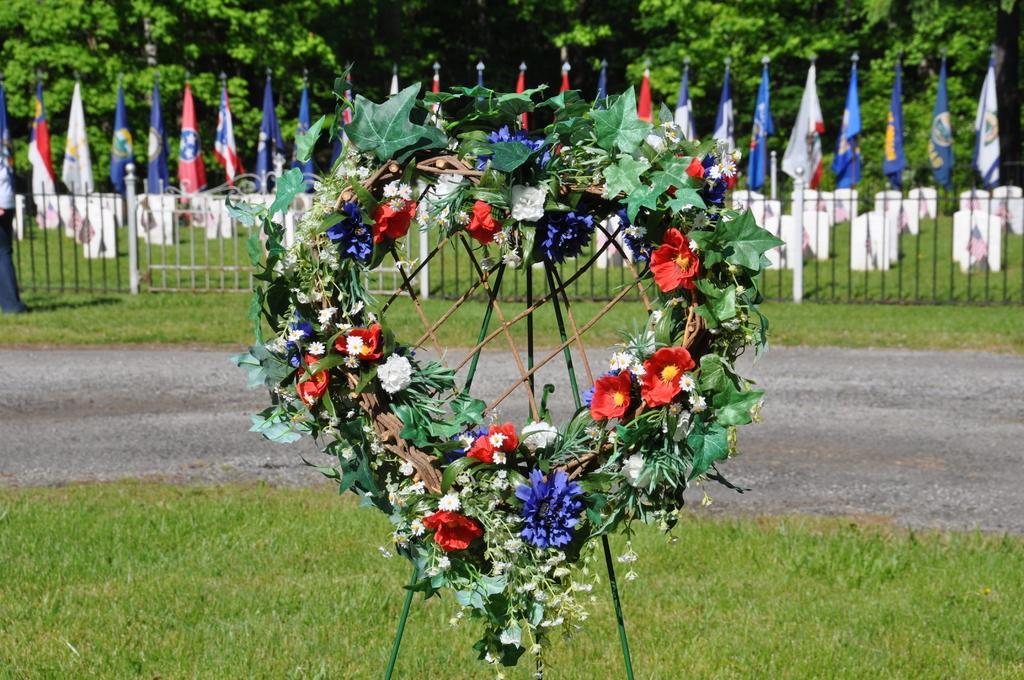Can you describe this image briefly? In this picture there is a garland on the stand. At the back there are flags behind the railing and there are tombstones behind the railing and there are trees. On the left side of the image there is a person standing at the railing. At the bottom there is grass and there is a road. 